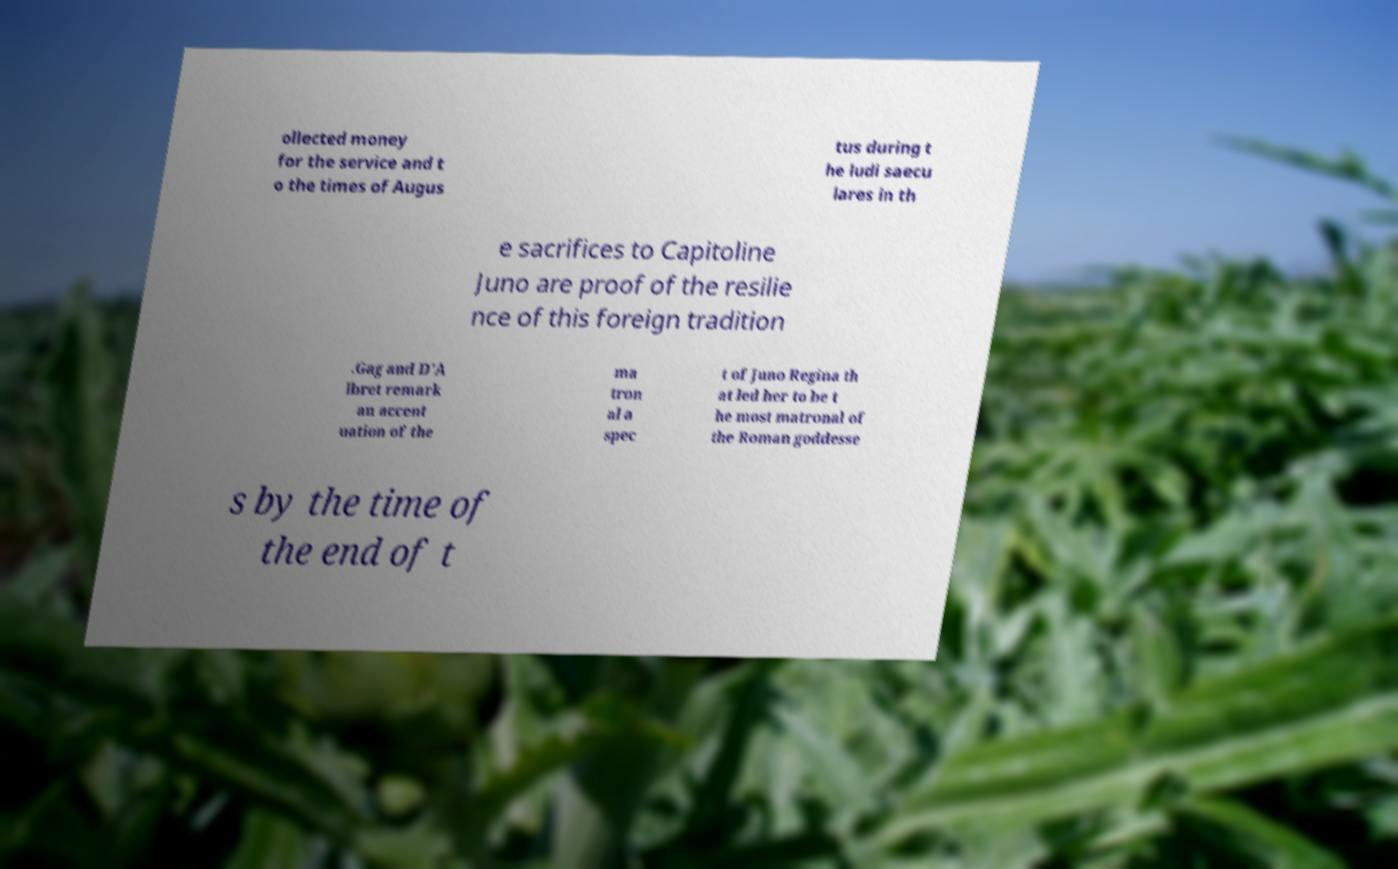What messages or text are displayed in this image? I need them in a readable, typed format. ollected money for the service and t o the times of Augus tus during t he ludi saecu lares in th e sacrifices to Capitoline Juno are proof of the resilie nce of this foreign tradition .Gag and D'A lbret remark an accent uation of the ma tron al a spec t of Juno Regina th at led her to be t he most matronal of the Roman goddesse s by the time of the end of t 